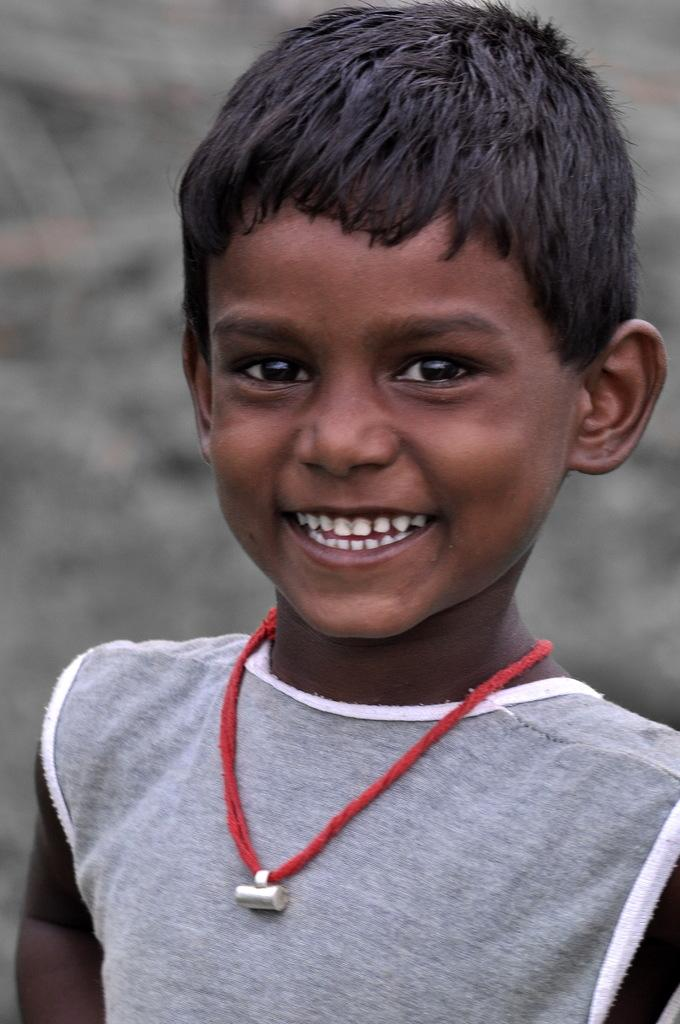What is the main subject in the foreground of the picture? There is a kid in the foreground of the picture. What is the kid wearing? The kid is wearing a t-shirt. What is the kid's facial expression? The kid is smiling. What can be seen in the background of the picture? There are other objects visible in the background of the picture. Can you tell me how many ants are crawling on the kid's t-shirt in the image? There are no ants visible on the kid's t-shirt in the image. Who is the kid's partner in the image? The provided facts do not mention any other person or partner in the image. 